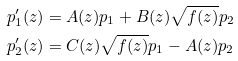Convert formula to latex. <formula><loc_0><loc_0><loc_500><loc_500>p _ { 1 } ^ { \prime } ( z ) & = A ( z ) p _ { 1 } + B ( z ) \sqrt { f ( z ) } p _ { 2 } \\ p _ { 2 } ^ { \prime } ( z ) & = C ( z ) \sqrt { f ( z ) } p _ { 1 } - A ( z ) p _ { 2 }</formula> 